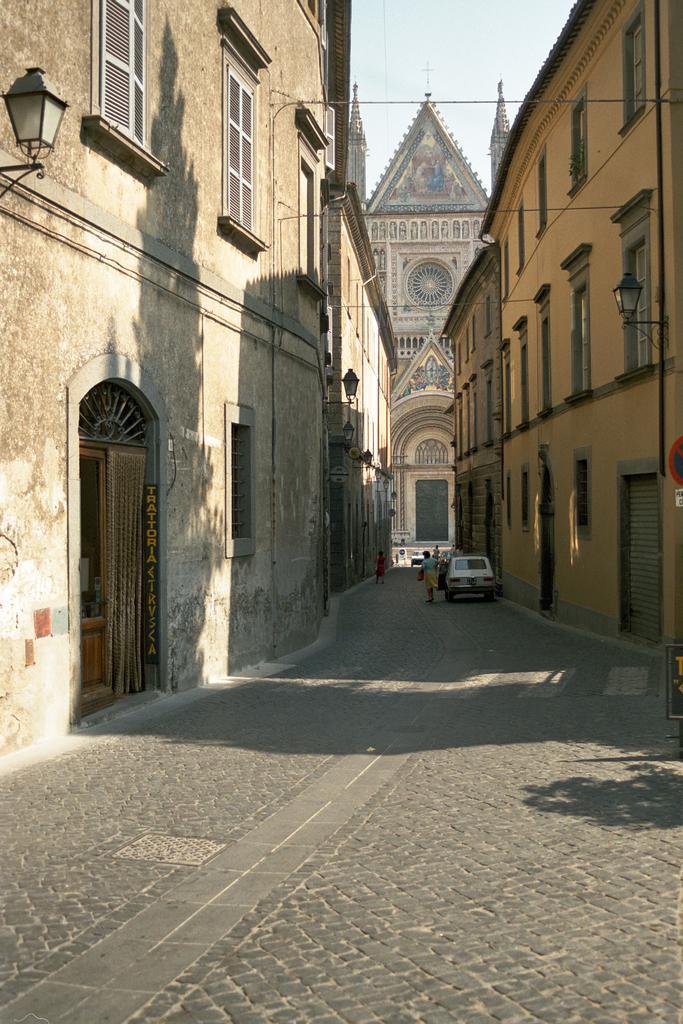Could you give a brief overview of what you see in this image? In this picture there are buildings on the right and left side of the image and there are lamps and windows on the buildings and there are people and a car in the center of the image and there is a clock building in the background area of the image. 